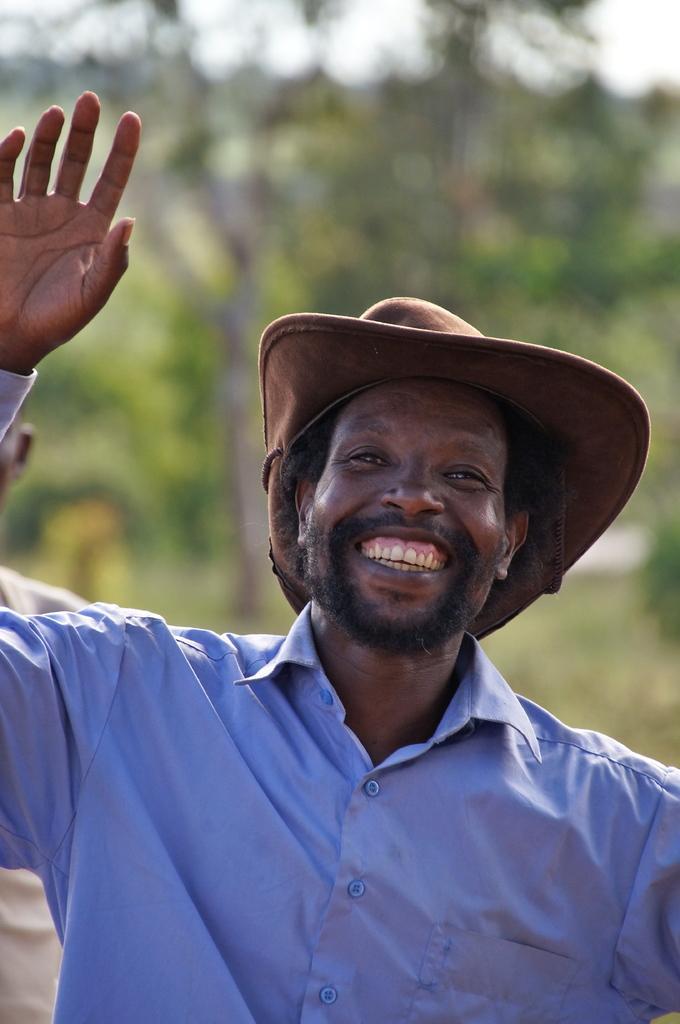Describe this image in one or two sentences. Here I can see a man wearing blue color shirt, smiling and giving pose for the picture. In the background there are some trees. 